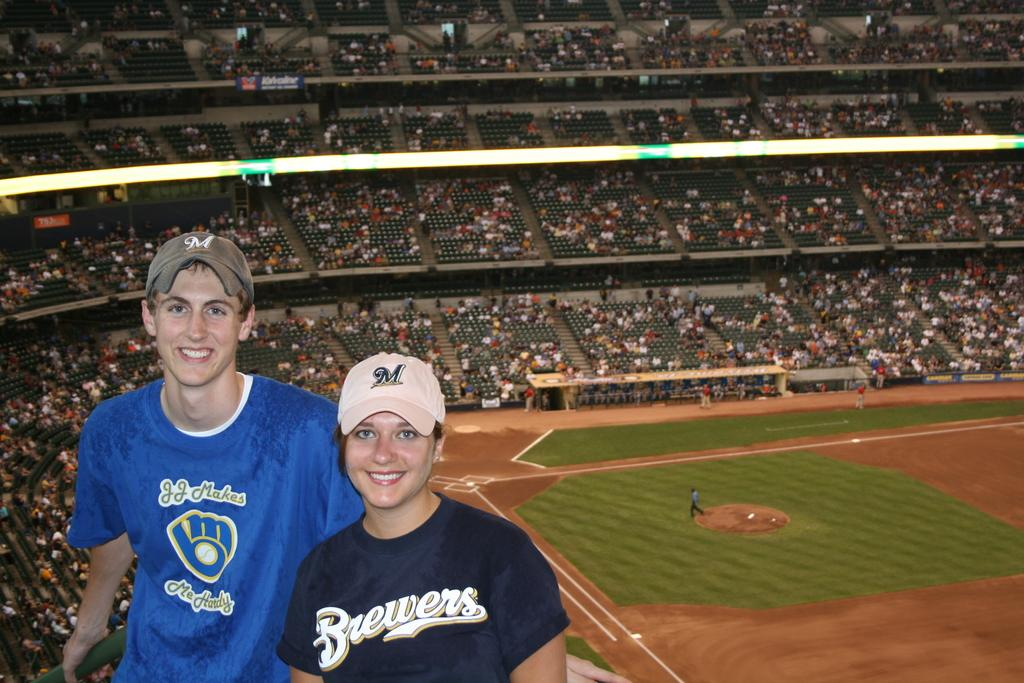Provide a one-sentence caption for the provided image. The couple is wearing Brewers shirts and hats. 